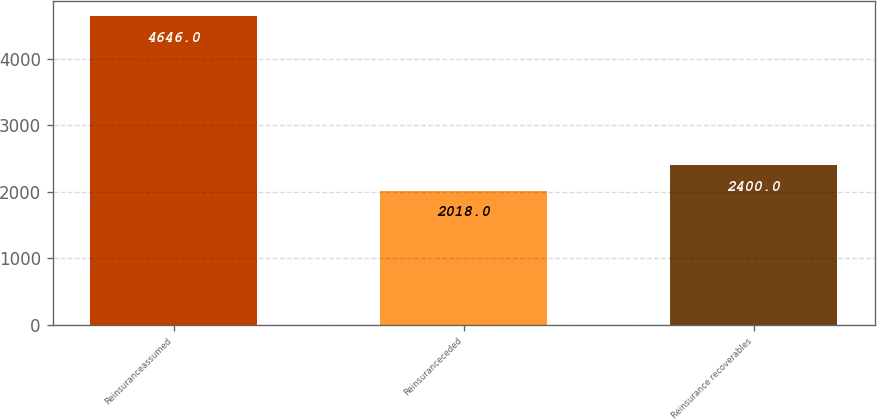Convert chart. <chart><loc_0><loc_0><loc_500><loc_500><bar_chart><fcel>Reinsuranceassumed<fcel>Reinsuranceceded<fcel>Reinsurance recoverables<nl><fcel>4646<fcel>2018<fcel>2400<nl></chart> 